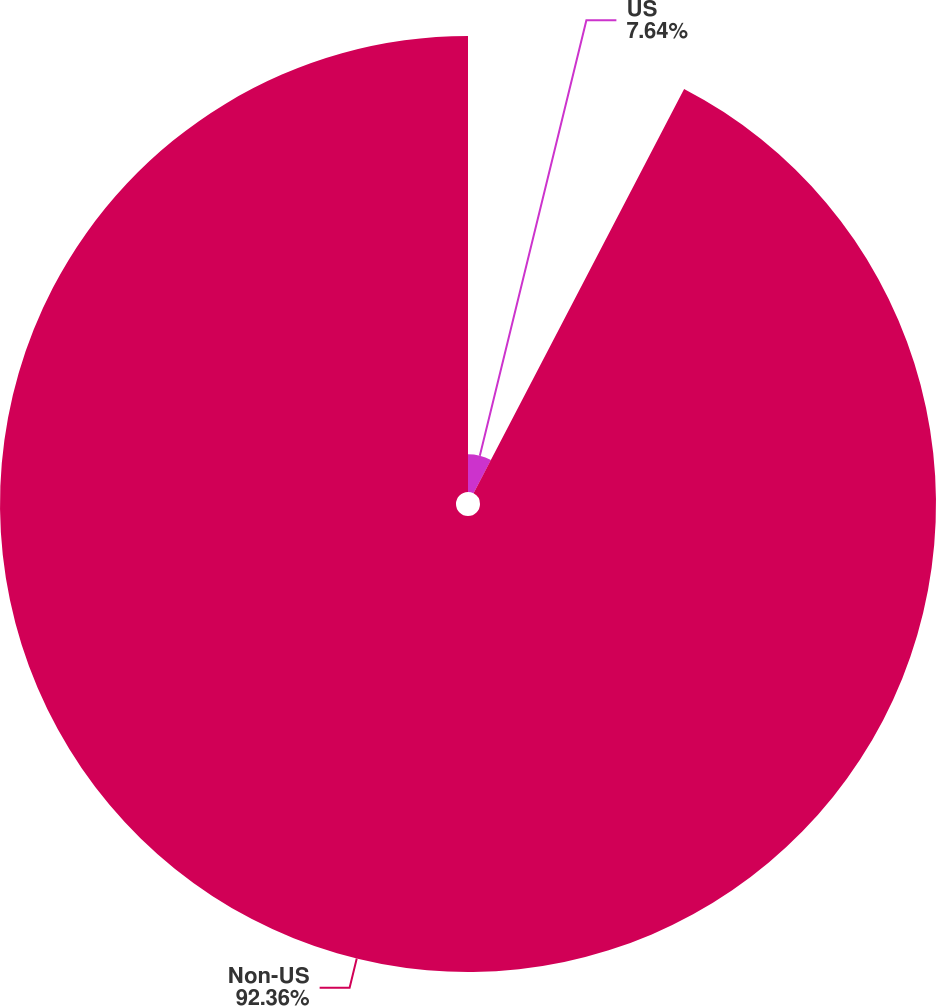Convert chart to OTSL. <chart><loc_0><loc_0><loc_500><loc_500><pie_chart><fcel>US<fcel>Non-US<nl><fcel>7.64%<fcel>92.36%<nl></chart> 